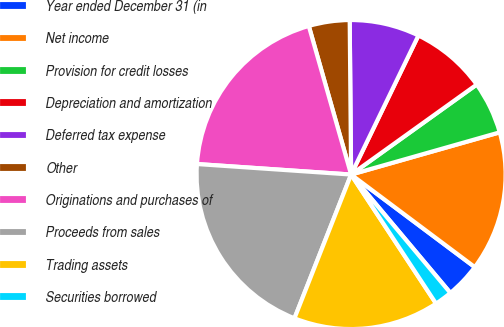Convert chart to OTSL. <chart><loc_0><loc_0><loc_500><loc_500><pie_chart><fcel>Year ended December 31 (in<fcel>Net income<fcel>Provision for credit losses<fcel>Depreciation and amortization<fcel>Deferred tax expense<fcel>Other<fcel>Originations and purchases of<fcel>Proceeds from sales<fcel>Trading assets<fcel>Securities borrowed<nl><fcel>3.67%<fcel>14.63%<fcel>5.49%<fcel>7.93%<fcel>7.32%<fcel>4.27%<fcel>19.5%<fcel>20.11%<fcel>15.24%<fcel>1.84%<nl></chart> 